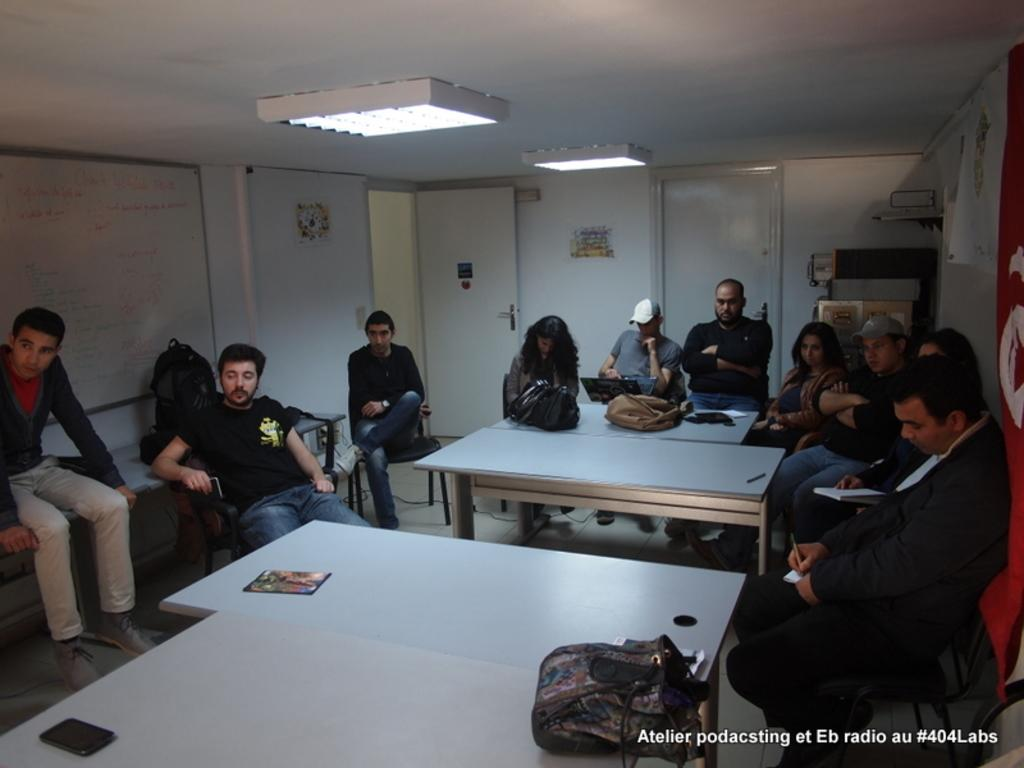Who or what can be seen in the image? There are people in the image. What are the people doing in the image? The people are sitting on chairs. What type of flower is growing on the playground in the image? There is no playground or flower present in the image; it only shows people sitting on chairs. 